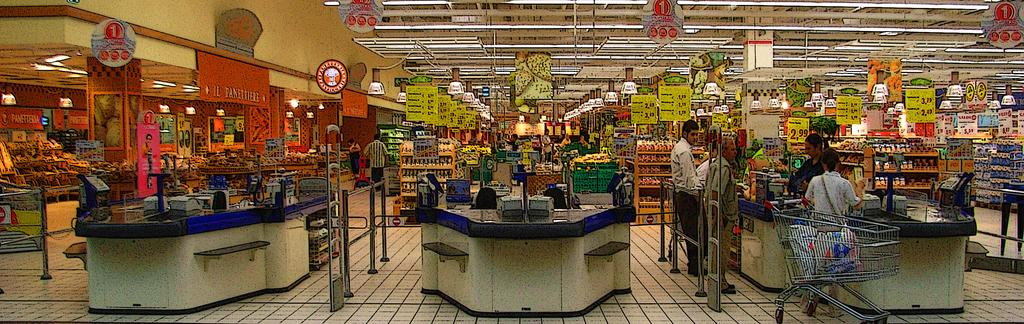Provide a one-sentence caption for the provided image. Supermarket signs display a number of different prices, including the figure $2.99. 